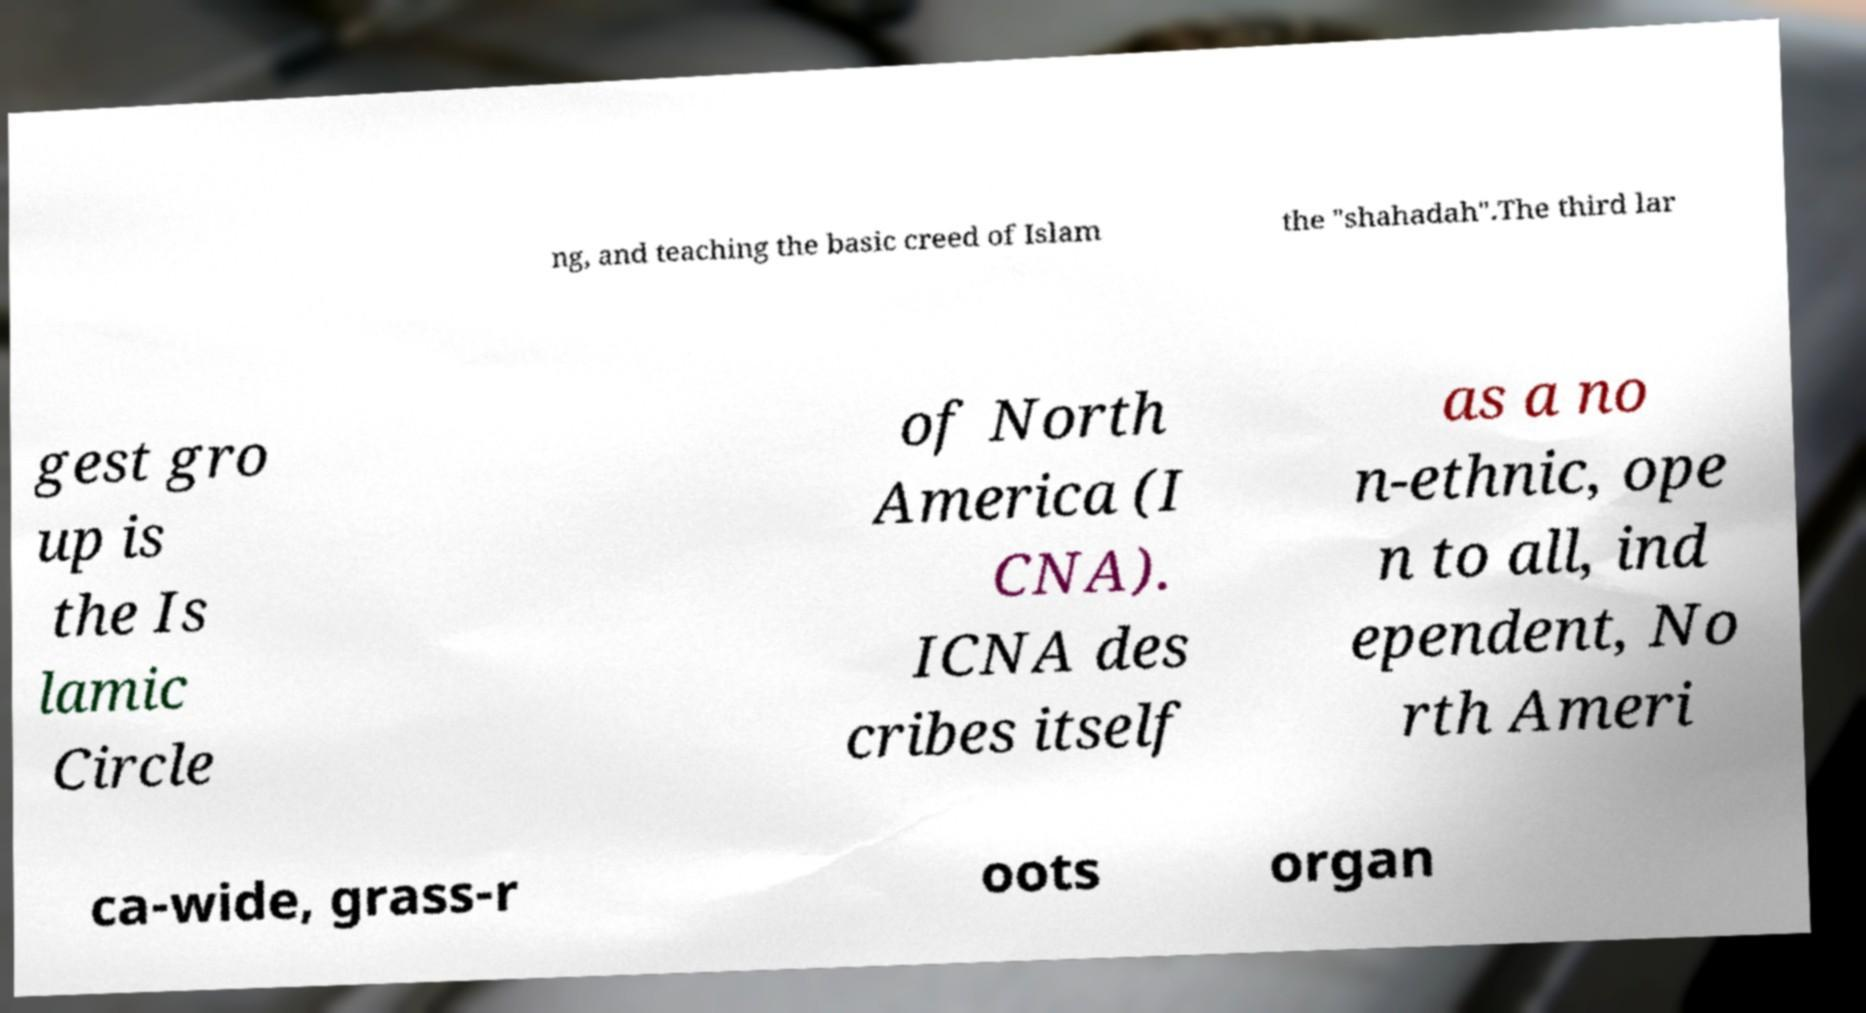Please read and relay the text visible in this image. What does it say? ng, and teaching the basic creed of Islam the "shahadah".The third lar gest gro up is the Is lamic Circle of North America (I CNA). ICNA des cribes itself as a no n-ethnic, ope n to all, ind ependent, No rth Ameri ca-wide, grass-r oots organ 